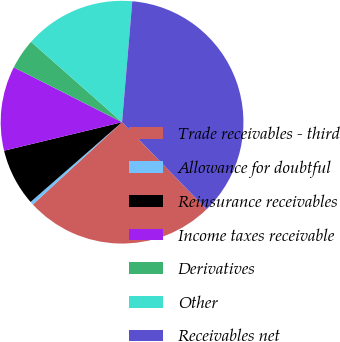<chart> <loc_0><loc_0><loc_500><loc_500><pie_chart><fcel>Trade receivables - third<fcel>Allowance for doubtful<fcel>Reinsurance receivables<fcel>Income taxes receivable<fcel>Derivatives<fcel>Other<fcel>Receivables net<nl><fcel>25.4%<fcel>0.45%<fcel>7.64%<fcel>11.24%<fcel>4.05%<fcel>14.83%<fcel>36.4%<nl></chart> 